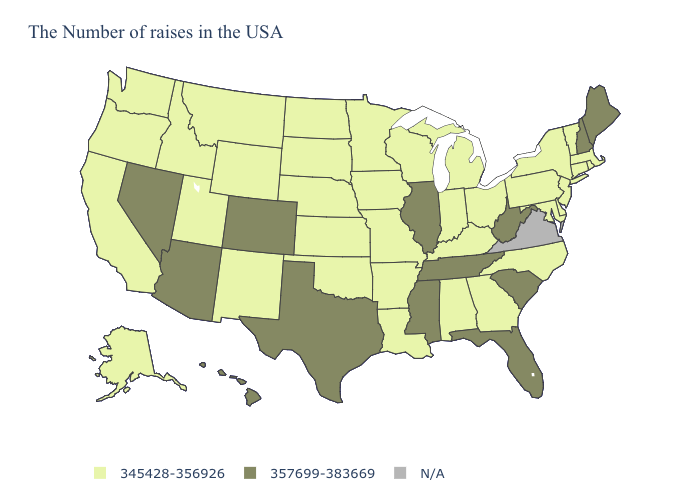What is the highest value in the USA?
Keep it brief. 357699-383669. What is the lowest value in the USA?
Answer briefly. 345428-356926. What is the value of Washington?
Answer briefly. 345428-356926. Among the states that border Wyoming , does Montana have the lowest value?
Keep it brief. Yes. Name the states that have a value in the range 357699-383669?
Short answer required. Maine, New Hampshire, South Carolina, West Virginia, Florida, Tennessee, Illinois, Mississippi, Texas, Colorado, Arizona, Nevada, Hawaii. Name the states that have a value in the range 357699-383669?
Answer briefly. Maine, New Hampshire, South Carolina, West Virginia, Florida, Tennessee, Illinois, Mississippi, Texas, Colorado, Arizona, Nevada, Hawaii. What is the value of Massachusetts?
Concise answer only. 345428-356926. Does Tennessee have the highest value in the South?
Give a very brief answer. Yes. Name the states that have a value in the range 357699-383669?
Quick response, please. Maine, New Hampshire, South Carolina, West Virginia, Florida, Tennessee, Illinois, Mississippi, Texas, Colorado, Arizona, Nevada, Hawaii. Which states have the highest value in the USA?
Be succinct. Maine, New Hampshire, South Carolina, West Virginia, Florida, Tennessee, Illinois, Mississippi, Texas, Colorado, Arizona, Nevada, Hawaii. What is the lowest value in states that border Kansas?
Answer briefly. 345428-356926. Among the states that border Iowa , does Wisconsin have the lowest value?
Short answer required. Yes. 